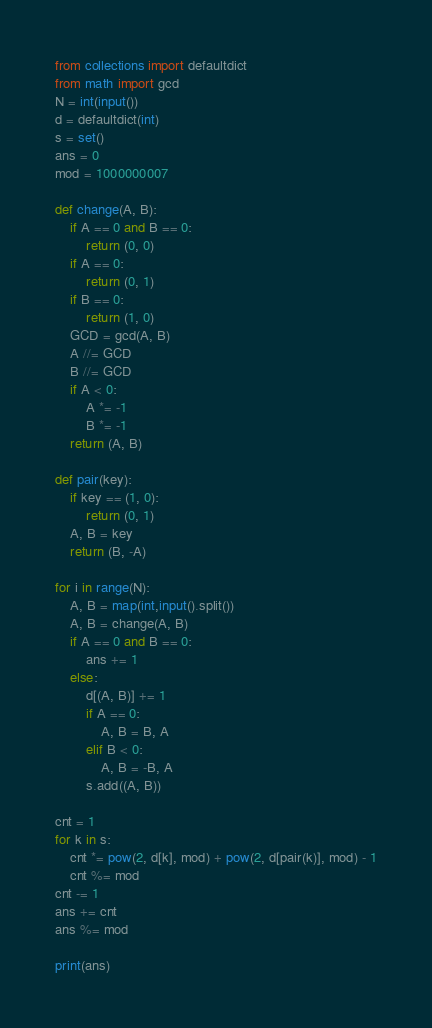<code> <loc_0><loc_0><loc_500><loc_500><_Python_>from collections import defaultdict
from math import gcd
N = int(input())
d = defaultdict(int)
s = set()
ans = 0
mod = 1000000007

def change(A, B):
    if A == 0 and B == 0:
        return (0, 0)
    if A == 0:
        return (0, 1)
    if B == 0:
        return (1, 0)
    GCD = gcd(A, B)
    A //= GCD
    B //= GCD
    if A < 0:
        A *= -1
        B *= -1
    return (A, B)

def pair(key):
    if key == (1, 0):
        return (0, 1)
    A, B = key
    return (B, -A)

for i in range(N):
    A, B = map(int,input().split())
    A, B = change(A, B)
    if A == 0 and B == 0:
        ans += 1
    else:
        d[(A, B)] += 1
        if A == 0:
            A, B = B, A
        elif B < 0:
            A, B = -B, A
        s.add((A, B))

cnt = 1
for k in s:
    cnt *= pow(2, d[k], mod) + pow(2, d[pair(k)], mod) - 1
    cnt %= mod
cnt -= 1
ans += cnt
ans %= mod

print(ans)</code> 